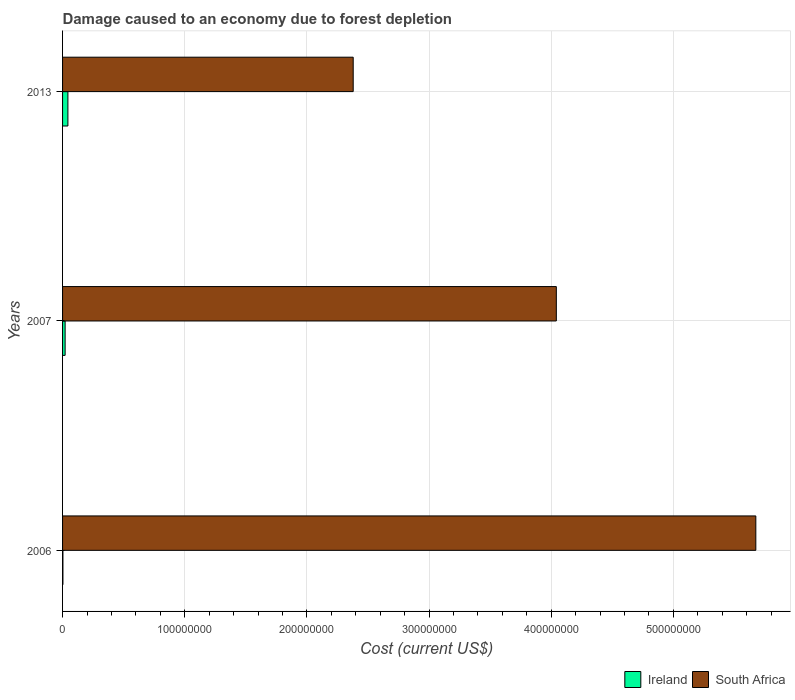How many different coloured bars are there?
Keep it short and to the point. 2. Are the number of bars on each tick of the Y-axis equal?
Offer a terse response. Yes. What is the cost of damage caused due to forest depletion in Ireland in 2013?
Ensure brevity in your answer.  4.37e+06. Across all years, what is the maximum cost of damage caused due to forest depletion in South Africa?
Your answer should be very brief. 5.67e+08. Across all years, what is the minimum cost of damage caused due to forest depletion in Ireland?
Your answer should be very brief. 2.94e+05. In which year was the cost of damage caused due to forest depletion in Ireland minimum?
Provide a short and direct response. 2006. What is the total cost of damage caused due to forest depletion in Ireland in the graph?
Your answer should be compact. 6.76e+06. What is the difference between the cost of damage caused due to forest depletion in South Africa in 2006 and that in 2007?
Your answer should be compact. 1.63e+08. What is the difference between the cost of damage caused due to forest depletion in South Africa in 2006 and the cost of damage caused due to forest depletion in Ireland in 2007?
Keep it short and to the point. 5.65e+08. What is the average cost of damage caused due to forest depletion in South Africa per year?
Provide a short and direct response. 4.03e+08. In the year 2006, what is the difference between the cost of damage caused due to forest depletion in Ireland and cost of damage caused due to forest depletion in South Africa?
Your answer should be compact. -5.67e+08. What is the ratio of the cost of damage caused due to forest depletion in Ireland in 2006 to that in 2007?
Ensure brevity in your answer.  0.14. Is the cost of damage caused due to forest depletion in Ireland in 2006 less than that in 2013?
Offer a very short reply. Yes. Is the difference between the cost of damage caused due to forest depletion in Ireland in 2006 and 2013 greater than the difference between the cost of damage caused due to forest depletion in South Africa in 2006 and 2013?
Keep it short and to the point. No. What is the difference between the highest and the second highest cost of damage caused due to forest depletion in Ireland?
Keep it short and to the point. 2.27e+06. What is the difference between the highest and the lowest cost of damage caused due to forest depletion in Ireland?
Offer a very short reply. 4.07e+06. What does the 1st bar from the top in 2006 represents?
Your response must be concise. South Africa. What does the 1st bar from the bottom in 2006 represents?
Give a very brief answer. Ireland. Are all the bars in the graph horizontal?
Provide a short and direct response. Yes. Are the values on the major ticks of X-axis written in scientific E-notation?
Your response must be concise. No. Where does the legend appear in the graph?
Give a very brief answer. Bottom right. How many legend labels are there?
Provide a succinct answer. 2. How are the legend labels stacked?
Keep it short and to the point. Horizontal. What is the title of the graph?
Give a very brief answer. Damage caused to an economy due to forest depletion. What is the label or title of the X-axis?
Provide a succinct answer. Cost (current US$). What is the label or title of the Y-axis?
Keep it short and to the point. Years. What is the Cost (current US$) in Ireland in 2006?
Offer a very short reply. 2.94e+05. What is the Cost (current US$) in South Africa in 2006?
Ensure brevity in your answer.  5.67e+08. What is the Cost (current US$) of Ireland in 2007?
Your answer should be compact. 2.10e+06. What is the Cost (current US$) of South Africa in 2007?
Keep it short and to the point. 4.04e+08. What is the Cost (current US$) in Ireland in 2013?
Your answer should be compact. 4.37e+06. What is the Cost (current US$) in South Africa in 2013?
Ensure brevity in your answer.  2.38e+08. Across all years, what is the maximum Cost (current US$) of Ireland?
Give a very brief answer. 4.37e+06. Across all years, what is the maximum Cost (current US$) in South Africa?
Provide a succinct answer. 5.67e+08. Across all years, what is the minimum Cost (current US$) in Ireland?
Provide a short and direct response. 2.94e+05. Across all years, what is the minimum Cost (current US$) in South Africa?
Keep it short and to the point. 2.38e+08. What is the total Cost (current US$) of Ireland in the graph?
Provide a succinct answer. 6.76e+06. What is the total Cost (current US$) of South Africa in the graph?
Keep it short and to the point. 1.21e+09. What is the difference between the Cost (current US$) of Ireland in 2006 and that in 2007?
Offer a very short reply. -1.81e+06. What is the difference between the Cost (current US$) in South Africa in 2006 and that in 2007?
Provide a short and direct response. 1.63e+08. What is the difference between the Cost (current US$) in Ireland in 2006 and that in 2013?
Offer a very short reply. -4.07e+06. What is the difference between the Cost (current US$) in South Africa in 2006 and that in 2013?
Your answer should be very brief. 3.30e+08. What is the difference between the Cost (current US$) of Ireland in 2007 and that in 2013?
Offer a terse response. -2.27e+06. What is the difference between the Cost (current US$) of South Africa in 2007 and that in 2013?
Make the answer very short. 1.66e+08. What is the difference between the Cost (current US$) of Ireland in 2006 and the Cost (current US$) of South Africa in 2007?
Ensure brevity in your answer.  -4.04e+08. What is the difference between the Cost (current US$) of Ireland in 2006 and the Cost (current US$) of South Africa in 2013?
Provide a succinct answer. -2.38e+08. What is the difference between the Cost (current US$) of Ireland in 2007 and the Cost (current US$) of South Africa in 2013?
Keep it short and to the point. -2.36e+08. What is the average Cost (current US$) in Ireland per year?
Keep it short and to the point. 2.25e+06. What is the average Cost (current US$) in South Africa per year?
Your answer should be compact. 4.03e+08. In the year 2006, what is the difference between the Cost (current US$) of Ireland and Cost (current US$) of South Africa?
Provide a short and direct response. -5.67e+08. In the year 2007, what is the difference between the Cost (current US$) of Ireland and Cost (current US$) of South Africa?
Provide a short and direct response. -4.02e+08. In the year 2013, what is the difference between the Cost (current US$) of Ireland and Cost (current US$) of South Africa?
Ensure brevity in your answer.  -2.34e+08. What is the ratio of the Cost (current US$) in Ireland in 2006 to that in 2007?
Your answer should be compact. 0.14. What is the ratio of the Cost (current US$) of South Africa in 2006 to that in 2007?
Your answer should be very brief. 1.4. What is the ratio of the Cost (current US$) of Ireland in 2006 to that in 2013?
Keep it short and to the point. 0.07. What is the ratio of the Cost (current US$) in South Africa in 2006 to that in 2013?
Give a very brief answer. 2.39. What is the ratio of the Cost (current US$) of Ireland in 2007 to that in 2013?
Offer a very short reply. 0.48. What is the ratio of the Cost (current US$) of South Africa in 2007 to that in 2013?
Provide a succinct answer. 1.7. What is the difference between the highest and the second highest Cost (current US$) in Ireland?
Your response must be concise. 2.27e+06. What is the difference between the highest and the second highest Cost (current US$) in South Africa?
Provide a short and direct response. 1.63e+08. What is the difference between the highest and the lowest Cost (current US$) of Ireland?
Make the answer very short. 4.07e+06. What is the difference between the highest and the lowest Cost (current US$) in South Africa?
Your response must be concise. 3.30e+08. 